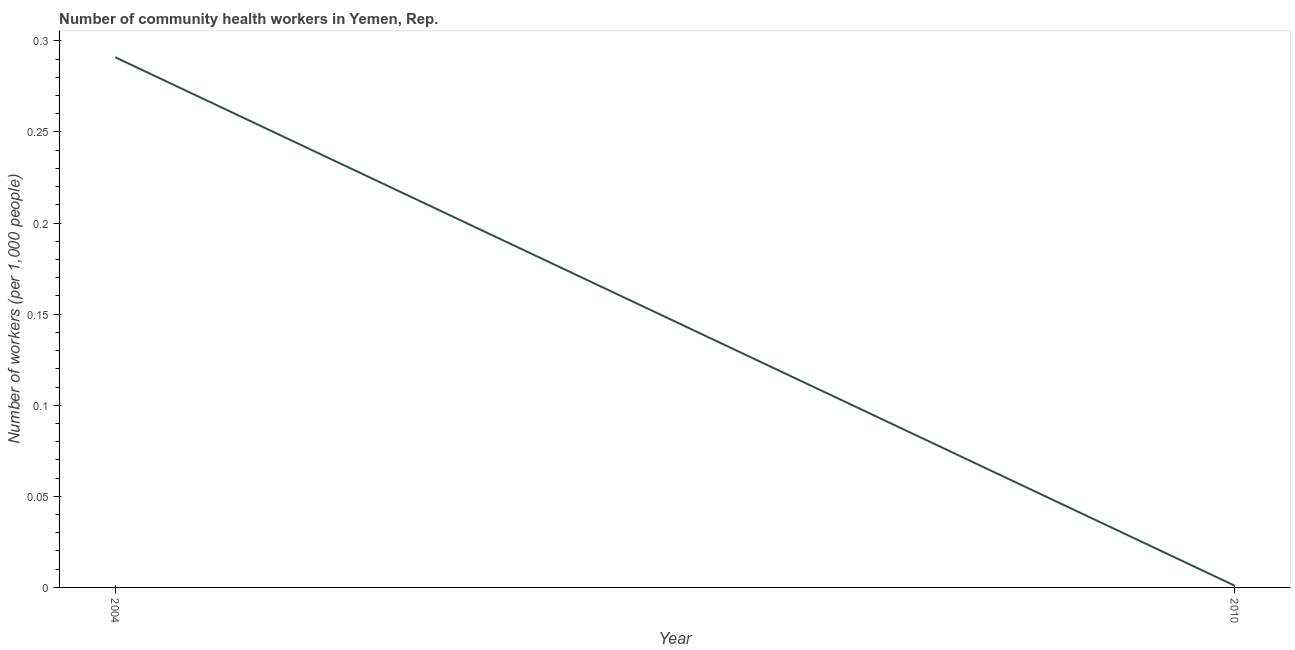Across all years, what is the maximum number of community health workers?
Your answer should be compact. 0.29. What is the sum of the number of community health workers?
Your answer should be very brief. 0.29. What is the difference between the number of community health workers in 2004 and 2010?
Make the answer very short. 0.29. What is the average number of community health workers per year?
Keep it short and to the point. 0.15. What is the median number of community health workers?
Ensure brevity in your answer.  0.15. What is the ratio of the number of community health workers in 2004 to that in 2010?
Keep it short and to the point. 291. Is the number of community health workers in 2004 less than that in 2010?
Your answer should be very brief. No. In how many years, is the number of community health workers greater than the average number of community health workers taken over all years?
Your answer should be very brief. 1. How many lines are there?
Give a very brief answer. 1. How many years are there in the graph?
Provide a short and direct response. 2. What is the difference between two consecutive major ticks on the Y-axis?
Your answer should be compact. 0.05. Does the graph contain any zero values?
Provide a short and direct response. No. Does the graph contain grids?
Make the answer very short. No. What is the title of the graph?
Your answer should be very brief. Number of community health workers in Yemen, Rep. What is the label or title of the X-axis?
Your answer should be compact. Year. What is the label or title of the Y-axis?
Your answer should be very brief. Number of workers (per 1,0 people). What is the Number of workers (per 1,000 people) in 2004?
Your answer should be compact. 0.29. What is the difference between the Number of workers (per 1,000 people) in 2004 and 2010?
Your answer should be compact. 0.29. What is the ratio of the Number of workers (per 1,000 people) in 2004 to that in 2010?
Offer a very short reply. 291. 